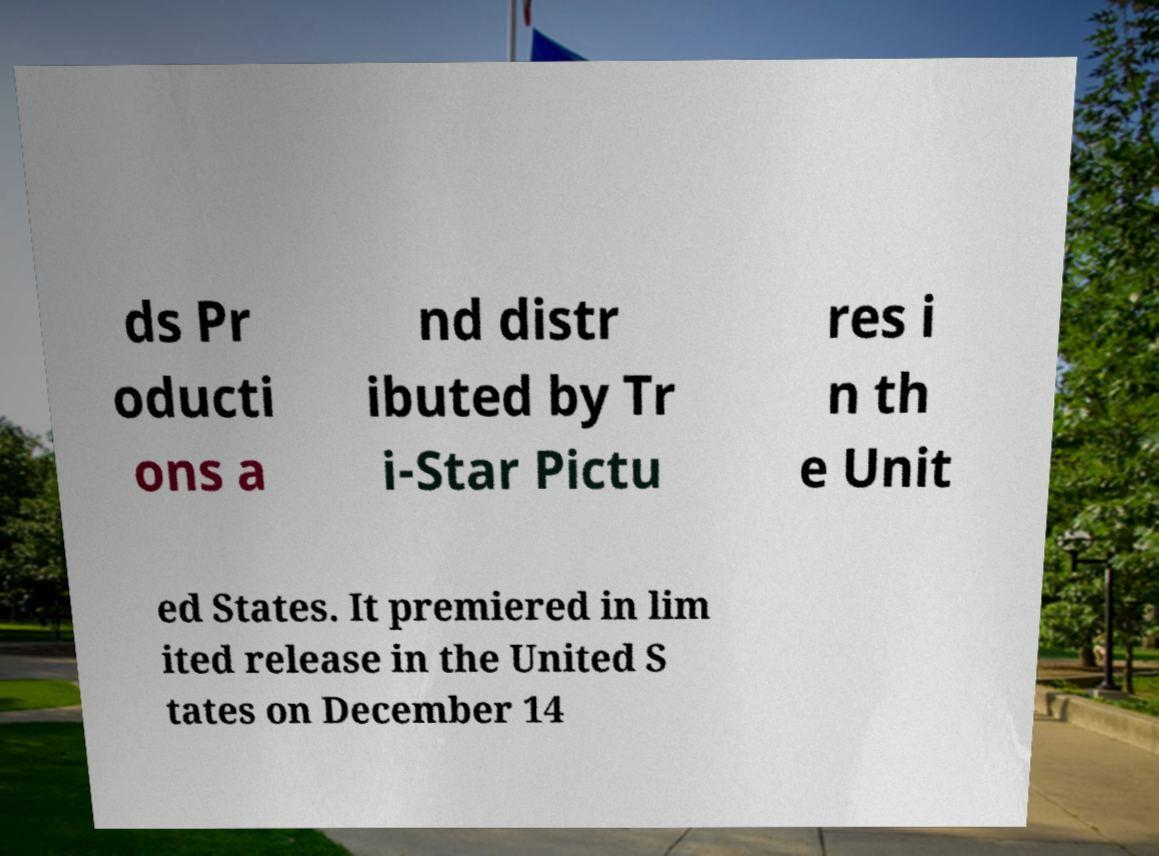There's text embedded in this image that I need extracted. Can you transcribe it verbatim? ds Pr oducti ons a nd distr ibuted by Tr i-Star Pictu res i n th e Unit ed States. It premiered in lim ited release in the United S tates on December 14 